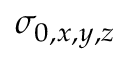<formula> <loc_0><loc_0><loc_500><loc_500>\sigma _ { 0 , x , y , z }</formula> 